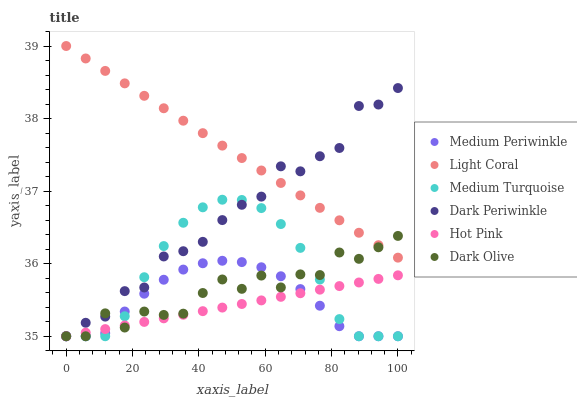Does Hot Pink have the minimum area under the curve?
Answer yes or no. Yes. Does Light Coral have the maximum area under the curve?
Answer yes or no. Yes. Does Dark Olive have the minimum area under the curve?
Answer yes or no. No. Does Dark Olive have the maximum area under the curve?
Answer yes or no. No. Is Light Coral the smoothest?
Answer yes or no. Yes. Is Dark Olive the roughest?
Answer yes or no. Yes. Is Medium Periwinkle the smoothest?
Answer yes or no. No. Is Medium Periwinkle the roughest?
Answer yes or no. No. Does Hot Pink have the lowest value?
Answer yes or no. Yes. Does Light Coral have the lowest value?
Answer yes or no. No. Does Light Coral have the highest value?
Answer yes or no. Yes. Does Dark Olive have the highest value?
Answer yes or no. No. Is Medium Periwinkle less than Light Coral?
Answer yes or no. Yes. Is Light Coral greater than Medium Periwinkle?
Answer yes or no. Yes. Does Light Coral intersect Dark Olive?
Answer yes or no. Yes. Is Light Coral less than Dark Olive?
Answer yes or no. No. Is Light Coral greater than Dark Olive?
Answer yes or no. No. Does Medium Periwinkle intersect Light Coral?
Answer yes or no. No. 